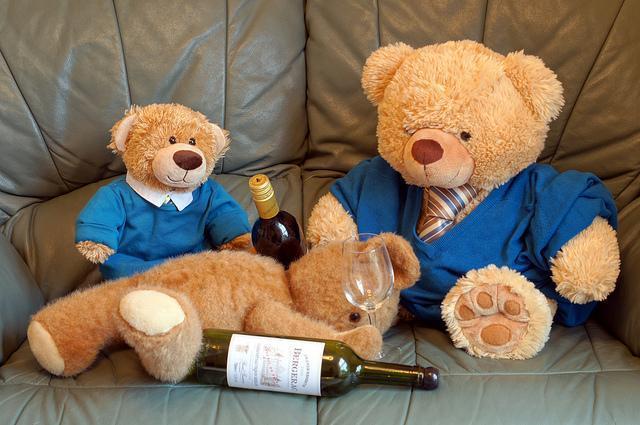How many paw pads do you count?
Give a very brief answer. 3. How many bottles are visible?
Give a very brief answer. 2. How many teddy bears are there?
Give a very brief answer. 3. How many cars have a surfboard on the roof?
Give a very brief answer. 0. 